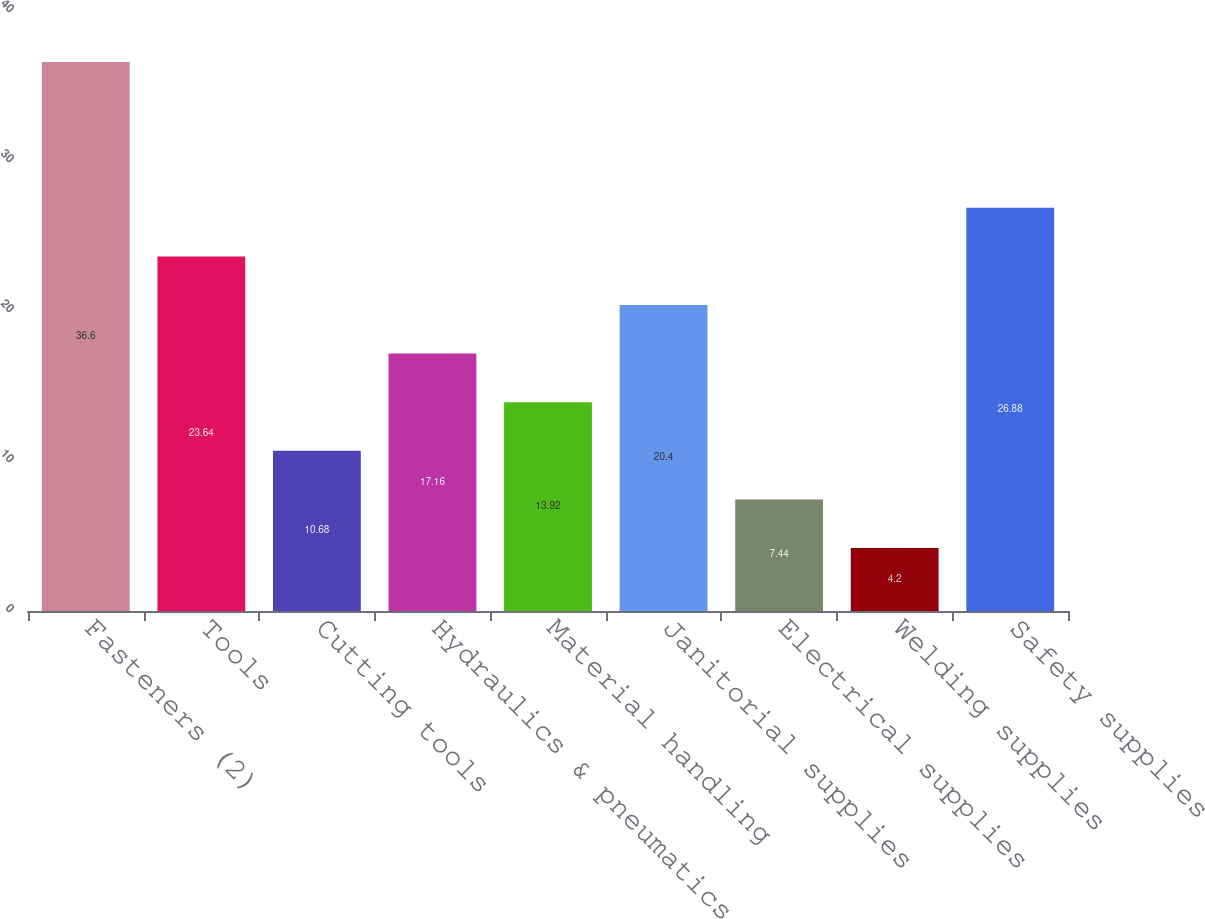Convert chart to OTSL. <chart><loc_0><loc_0><loc_500><loc_500><bar_chart><fcel>Fasteners (2)<fcel>Tools<fcel>Cutting tools<fcel>Hydraulics & pneumatics<fcel>Material handling<fcel>Janitorial supplies<fcel>Electrical supplies<fcel>Welding supplies<fcel>Safety supplies<nl><fcel>36.6<fcel>23.64<fcel>10.68<fcel>17.16<fcel>13.92<fcel>20.4<fcel>7.44<fcel>4.2<fcel>26.88<nl></chart> 